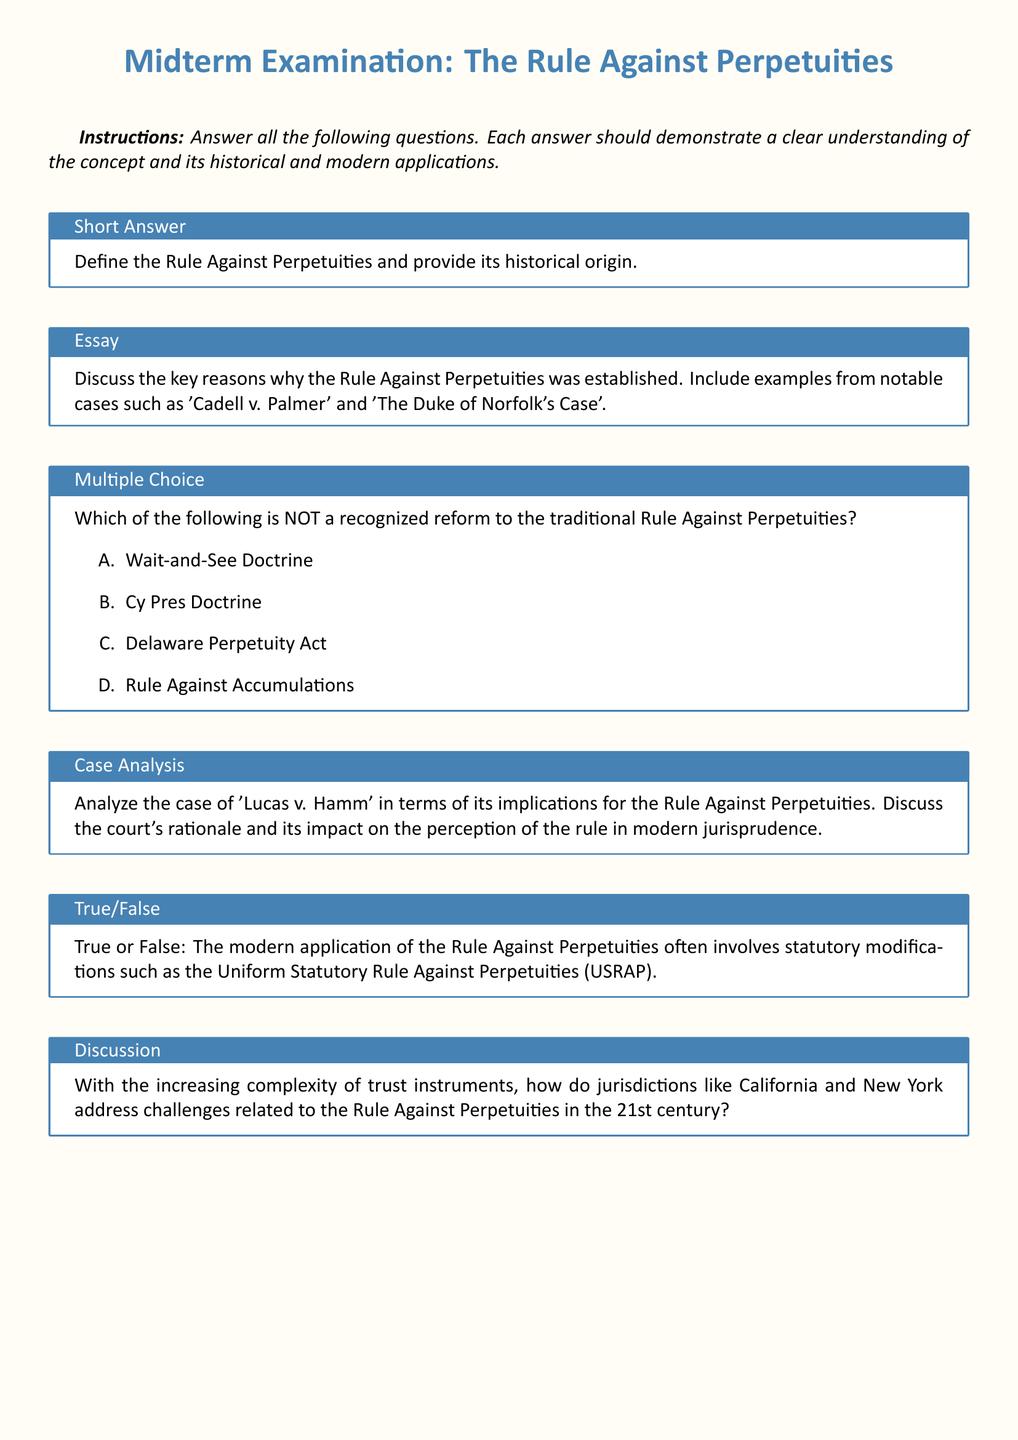What is the title of the midterm examination? The title provided at the top of the document specifies the focus of the exam, which is on the Rule Against Perpetuities.
Answer: The Rule Against Perpetuities How many sections are there in the midterm examination? The document outlines six different sections for the exam, indicating the breadth of topics covered.
Answer: Six What notable case is mentioned in the essay question? The essay question highlights specific landmark cases that relate to the Rule Against Perpetuities, with one being specifically named.
Answer: Cadell v. Palmer Which doctrine is NOT reform to the traditional Rule Against Perpetuities? The multiple-choice question asks for identification of a doctrine not associated with reforms of the traditional rule.
Answer: Rule Against Accumulations True or False: The document states that the modern application of the Rule often involves statutory modifications. The true/false question directly addresses whether current practices incorporate legal modifications as mentioned.
Answer: True What is the specific name of the uniform statute mentioned in the true/false question? The true/false question references a specific legislative framework that guides modern applications of the Rule.
Answer: Uniform Statutory Rule Against Perpetuities (USRAP) 